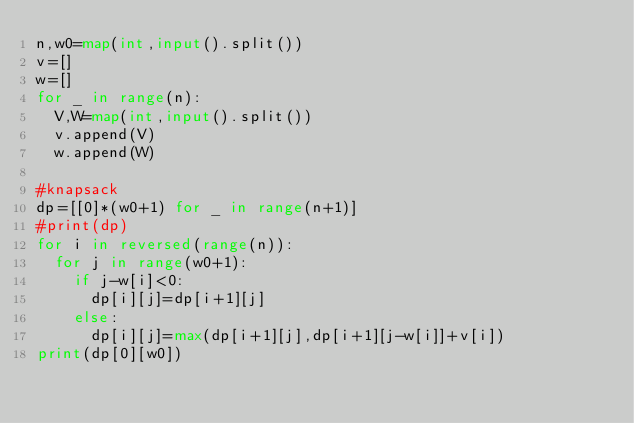Convert code to text. <code><loc_0><loc_0><loc_500><loc_500><_Python_>n,w0=map(int,input().split())
v=[]
w=[]
for _ in range(n):
	V,W=map(int,input().split())
	v.append(V)
	w.append(W)

#knapsack
dp=[[0]*(w0+1) for _ in range(n+1)]
#print(dp)
for i in reversed(range(n)):
	for j in range(w0+1):
		if j-w[i]<0:
			dp[i][j]=dp[i+1][j]
		else:
			dp[i][j]=max(dp[i+1][j],dp[i+1][j-w[i]]+v[i])
print(dp[0][w0])
</code> 